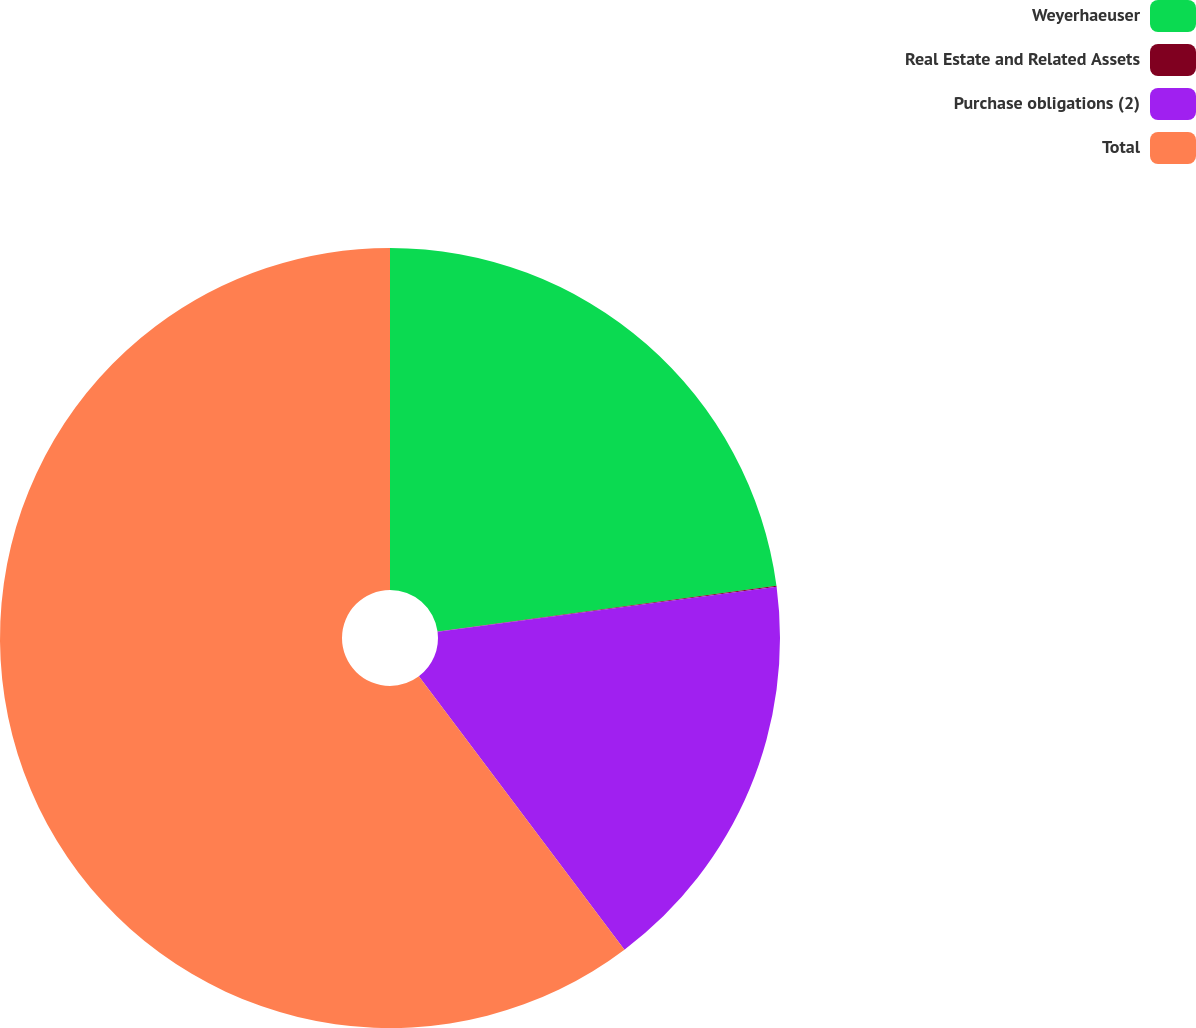<chart> <loc_0><loc_0><loc_500><loc_500><pie_chart><fcel>Weyerhaeuser<fcel>Real Estate and Related Assets<fcel>Purchase obligations (2)<fcel>Total<nl><fcel>22.86%<fcel>0.04%<fcel>16.84%<fcel>60.27%<nl></chart> 